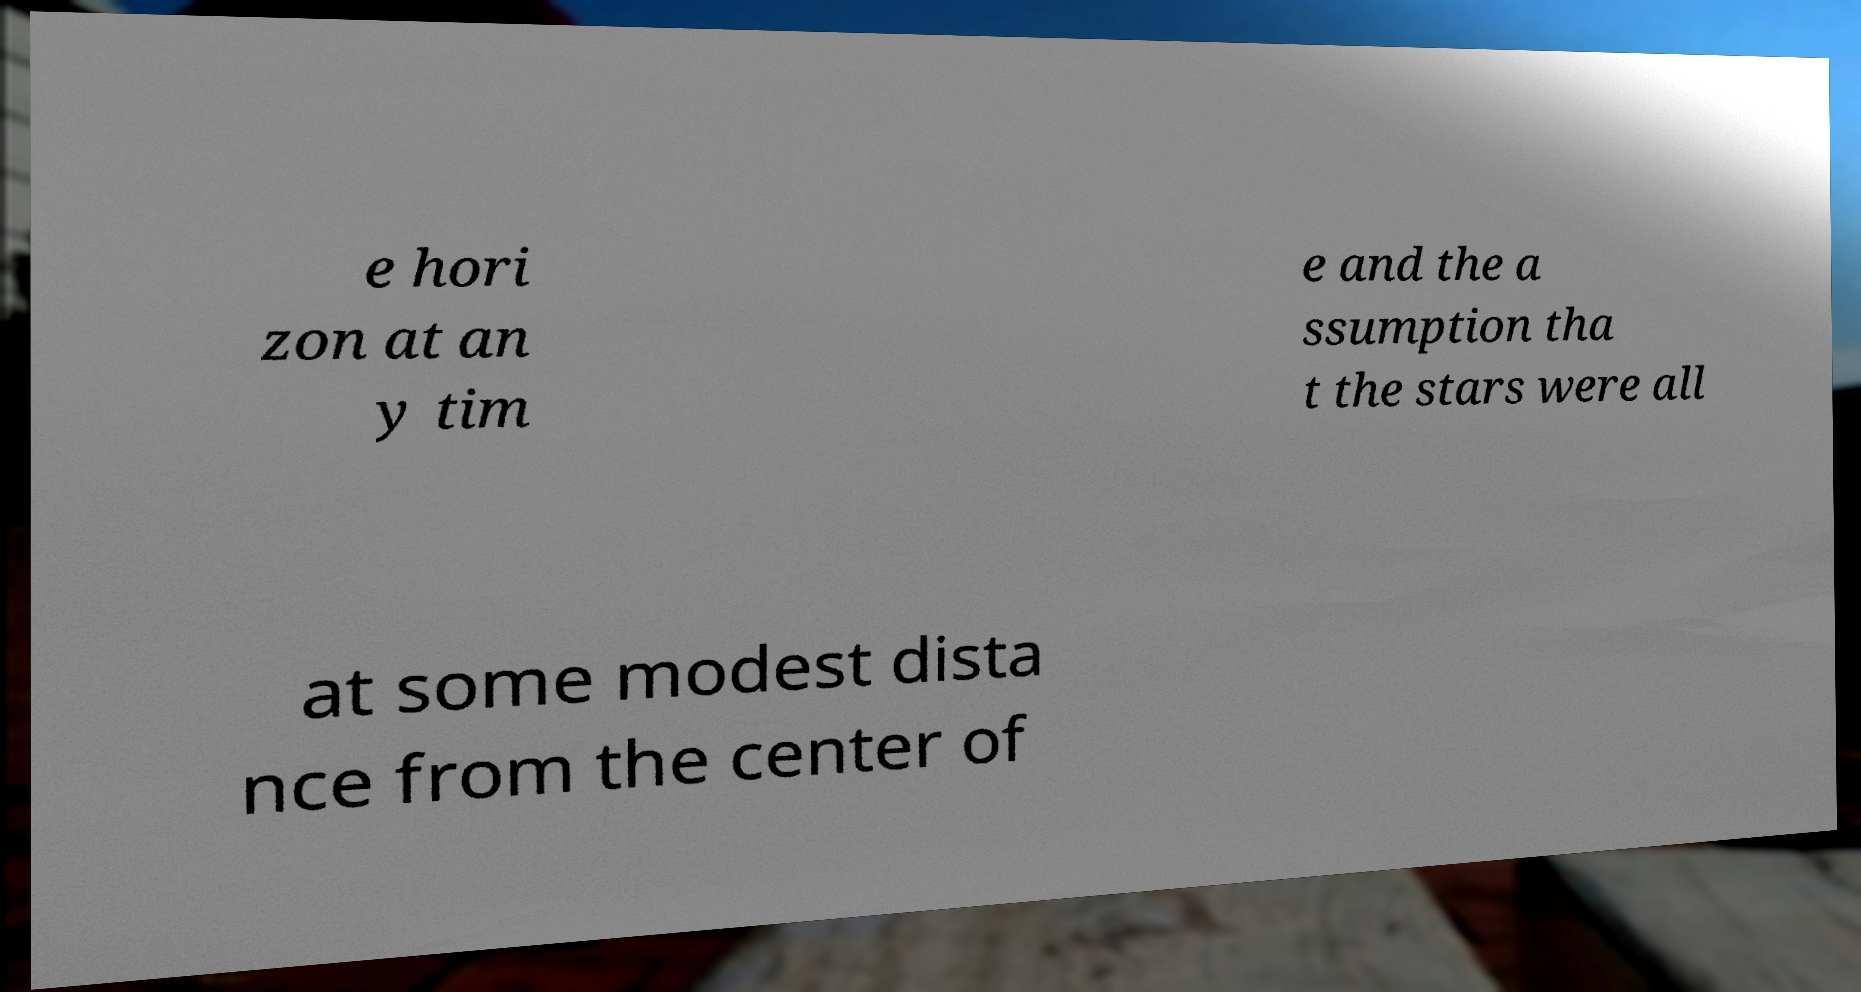Can you read and provide the text displayed in the image?This photo seems to have some interesting text. Can you extract and type it out for me? e hori zon at an y tim e and the a ssumption tha t the stars were all at some modest dista nce from the center of 